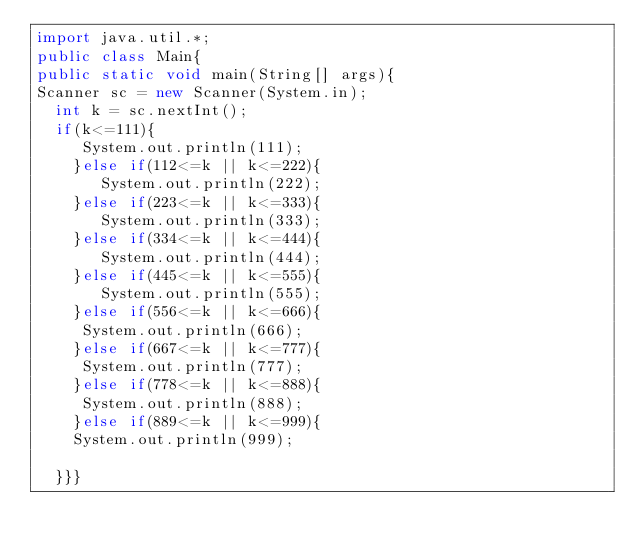Convert code to text. <code><loc_0><loc_0><loc_500><loc_500><_Java_>import java.util.*;
public class Main{
public static void main(String[] args){
Scanner sc = new Scanner(System.in);
  int k = sc.nextInt();
  if(k<=111){
     System.out.println(111);
    }else if(112<=k || k<=222){
       System.out.println(222);
    }else if(223<=k || k<=333){
       System.out.println(333);
    }else if(334<=k || k<=444){
       System.out.println(444);
    }else if(445<=k || k<=555){
       System.out.println(555);
    }else if(556<=k || k<=666){
     System.out.println(666);
    }else if(667<=k || k<=777){
     System.out.println(777);
    }else if(778<=k || k<=888){
     System.out.println(888);
    }else if(889<=k || k<=999){
    System.out.println(999);
  
  }}}</code> 